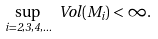<formula> <loc_0><loc_0><loc_500><loc_500>\sup _ { i = 2 , 3 , 4 , \dots } \ V o l ( M _ { i } ) < \infty .</formula> 